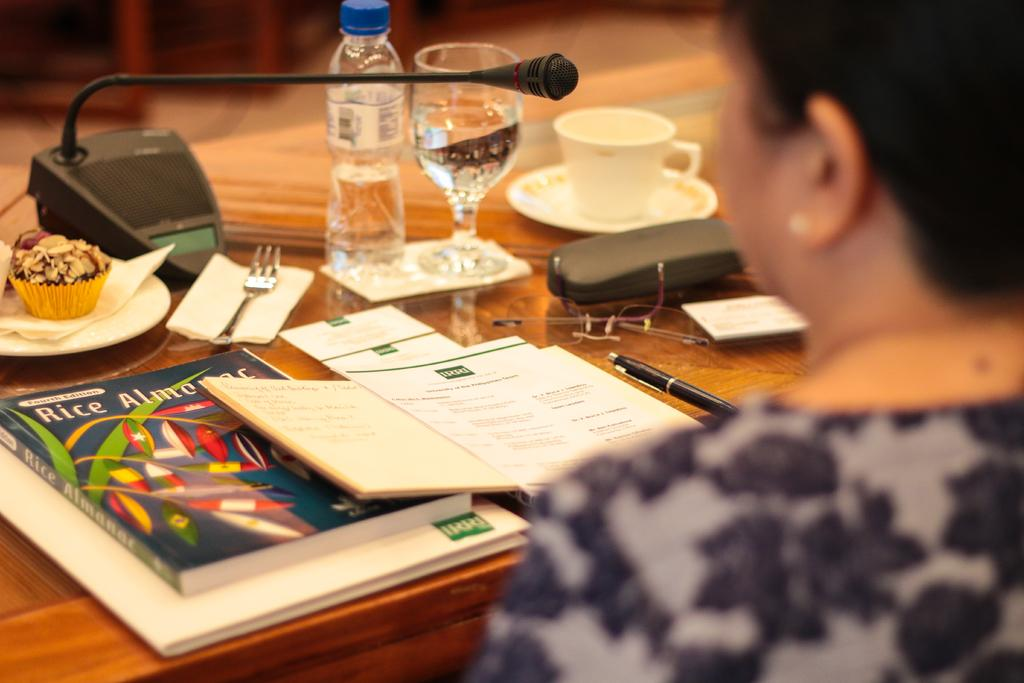<image>
Offer a succinct explanation of the picture presented. a woman sitting at a table with a book that says Rice at the top of it 